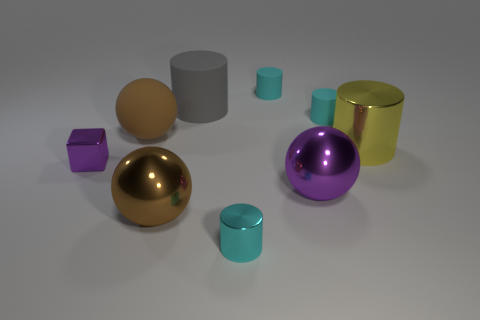Is the size of the metallic block the same as the matte ball?
Make the answer very short. No. Are there any big gray matte balls?
Give a very brief answer. No. The shiny ball that is the same color as the block is what size?
Make the answer very short. Large. How big is the cyan matte cylinder in front of the cyan rubber cylinder that is on the left side of the cyan rubber thing that is right of the big purple metal ball?
Provide a short and direct response. Small. How many tiny blue objects are the same material as the cube?
Your answer should be compact. 0. How many yellow objects are the same size as the gray cylinder?
Ensure brevity in your answer.  1. There is a brown object that is to the left of the large brown ball that is to the right of the brown sphere that is behind the metallic cube; what is its material?
Give a very brief answer. Rubber. How many things are either tiny red metallic cylinders or large purple shiny spheres?
Your answer should be very brief. 1. The cyan metal object has what shape?
Your response must be concise. Cylinder. What is the shape of the large thing to the left of the large ball in front of the purple sphere?
Your response must be concise. Sphere. 